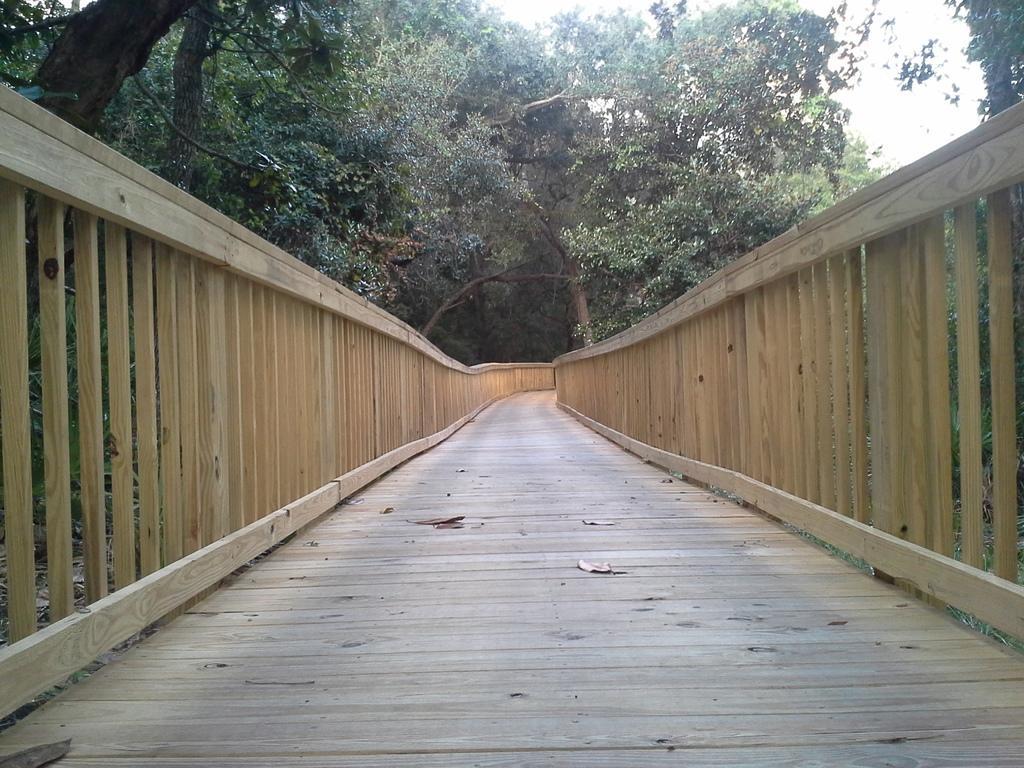In one or two sentences, can you explain what this image depicts? In this picture we can see dried leaves on a path, fences, trees and in the background we can see the sky. 